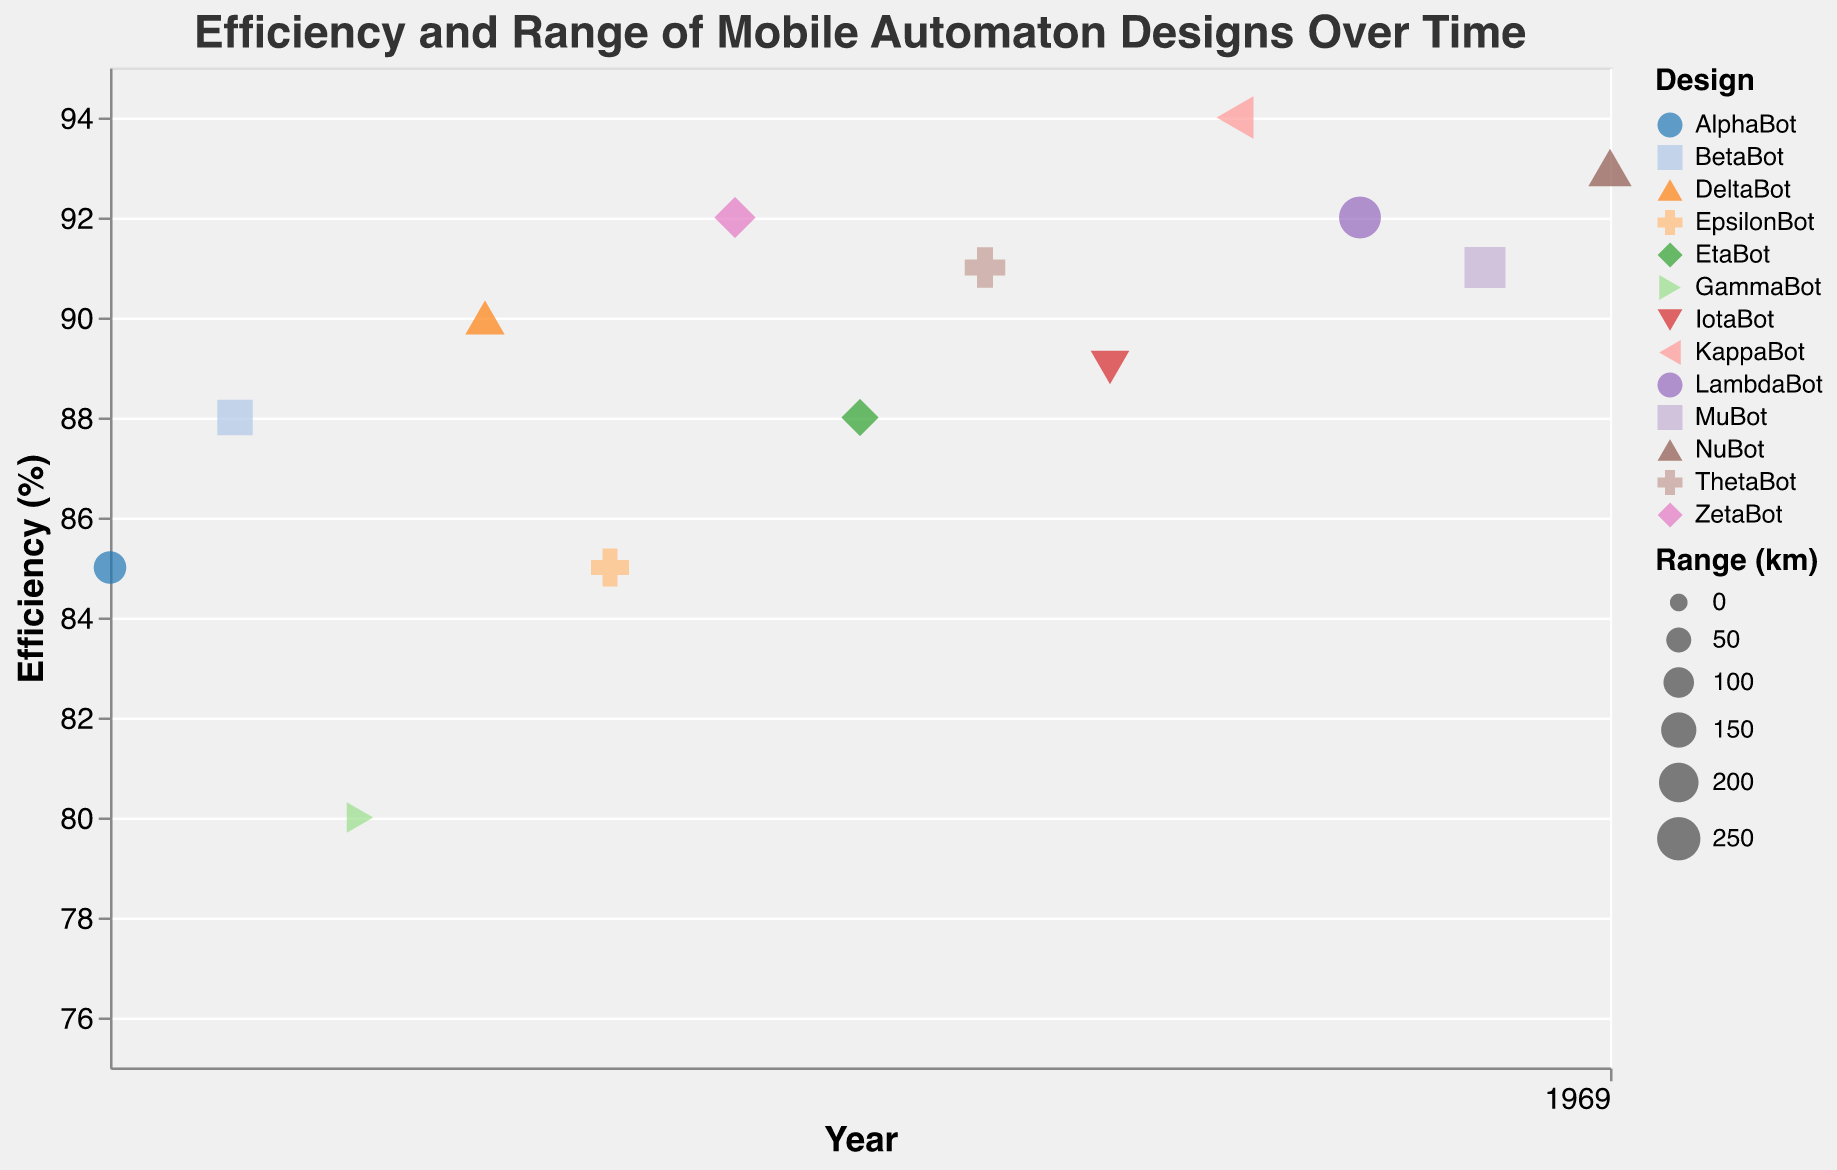What is the title of the plot? The title is usually displayed at the top of the plot, indicating the main topic or what the plot represents. The title here is clearly "Efficiency and Range of Mobile Automaton Designs Over Time".
Answer: Efficiency and Range of Mobile Automaton Designs Over Time How many designs are displayed in the figure? Count the unique entries in the "Design" field. There are 13 unique designs: AlphaBot, BetaBot, GammaBot, DeltaBot, EpsilonBot, ZetaBot, EtaBot, ThetaBot, IotaBot, KappaBot, LambdaBot, MuBot, and NuBot.
Answer: 13 Which design has the highest efficiency? Look for the design with the highest value on the Efficiency axis. KappaBot (2019) and NuBot (2022) have the highest efficiency values at 94%.
Answer: KappaBot and NuBot What’s the range of BetaBot in 2011? Each point includes a tooltip that specifies the range for each design in each year. For BetaBot in 2011, the range is given as 150 km.
Answer: 150 km How does the efficiency of ThetaBot in 2017 compare to that of EtaBot in 2016? Refer to the Efficiency axis and compare the points for ThetaBot (2017) and EtaBot (2016) to see which is higher. ThetaBot (91%) has a higher efficiency than EtaBot (88%).
Answer: ThetaBot has higher efficiency Calculate the average efficiency of all designs in the year 2021. The specific designs and their efficiency values for 2021 are to be identified. MuBot has an efficiency of 91% in that year. Since MuBot is the only design from 2021, the average would just be the efficiency of MuBot itself.
Answer: 91% Which year features the highest number of designs with efficiency above 90%? Count the number of designs with an efficiency greater than 90% for each year. In 2022, there are NuBot (93%), in 2020 there are LambdaBot (92%) and in 2019, KappaBot (94%). The highest number is in 2019 and 2020, each featuring 2 designs above 90%.
Answer: 2019 and 2020 Find the design with the highest range in the entire dataset. Check the tooltip on each point to determine which design has the highest range value. NuBot in 2022 has the highest range of 250 km.
Answer: NuBot Compare the efficiency trend from 2010 to 2022. Has the efficiency generally increased, decreased, or stayed the same? Observe the y-axis values for efficiency over the years. From 2010 to 2022, the general trend shows an increase, with efficiency values going from 85% (2010) to 93% (2022), despite some fluctuations.
Answer: Increased Which design in 2015 had the most substantial range, and how does it compare to the range of 2020? Look at the data points for the years 2015 and 2020 and identify the range values. In 2015, ZetaBot has a range of 220 km, while in 2020, LambdaBot has a range of 230 km. Comparing these, LambdaBot in 2020 has a higher range.
Answer: LambdaBot has higher range in 2020 